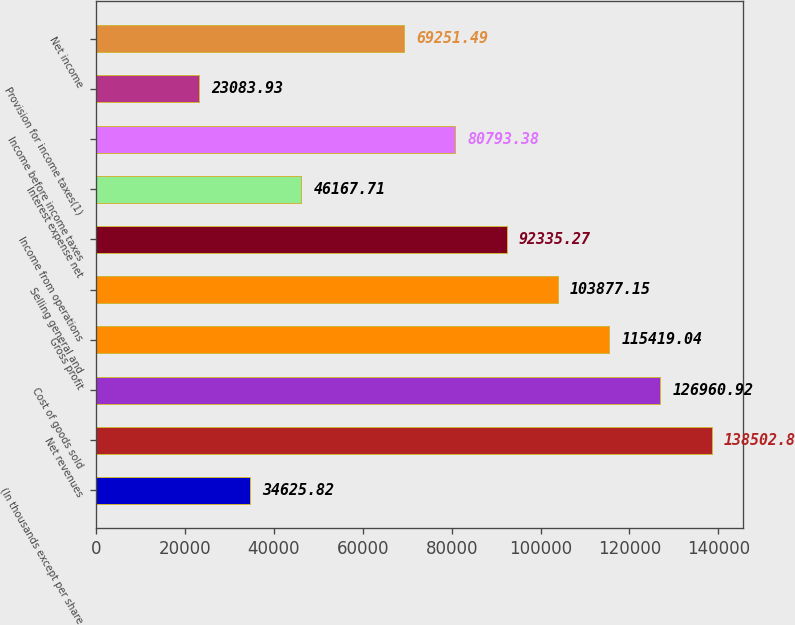Convert chart to OTSL. <chart><loc_0><loc_0><loc_500><loc_500><bar_chart><fcel>(In thousands except per share<fcel>Net revenues<fcel>Cost of goods sold<fcel>Gross profit<fcel>Selling general and<fcel>Income from operations<fcel>Interest expense net<fcel>Income before income taxes<fcel>Provision for income taxes(1)<fcel>Net income<nl><fcel>34625.8<fcel>138503<fcel>126961<fcel>115419<fcel>103877<fcel>92335.3<fcel>46167.7<fcel>80793.4<fcel>23083.9<fcel>69251.5<nl></chart> 